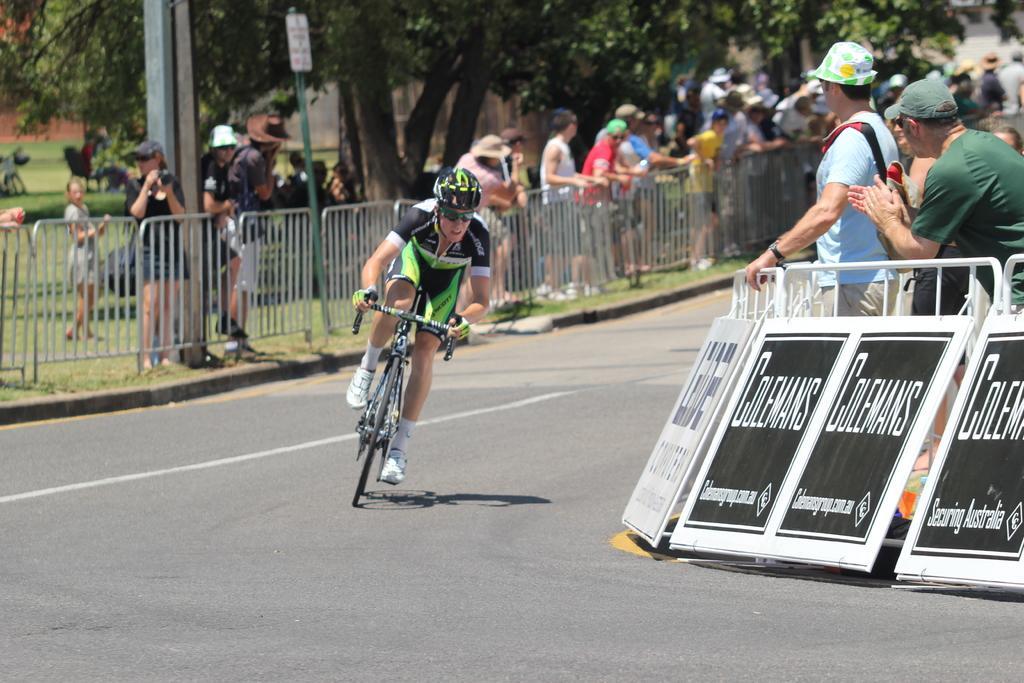Could you give a brief overview of what you see in this image? In the center of the image a man is riding a bicycle and wearing a helmet. In the background of the image we can see a group of people are standing. At the top of the image trees are present. At the bottom of the image road is there. On the right side of the image boards are present. On the left side of the image we can see grass, barricades, pole, sign boards, chair, a building are present. 